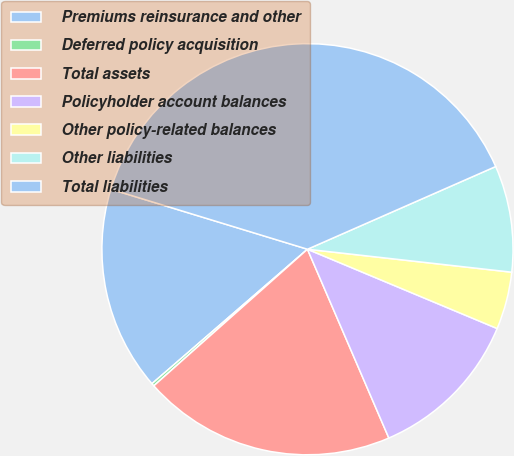Convert chart. <chart><loc_0><loc_0><loc_500><loc_500><pie_chart><fcel>Premiums reinsurance and other<fcel>Deferred policy acquisition<fcel>Total assets<fcel>Policyholder account balances<fcel>Other policy-related balances<fcel>Other liabilities<fcel>Total liabilities<nl><fcel>16.06%<fcel>0.22%<fcel>19.91%<fcel>12.22%<fcel>4.52%<fcel>8.37%<fcel>38.69%<nl></chart> 